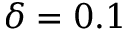Convert formula to latex. <formula><loc_0><loc_0><loc_500><loc_500>\delta = 0 . 1</formula> 